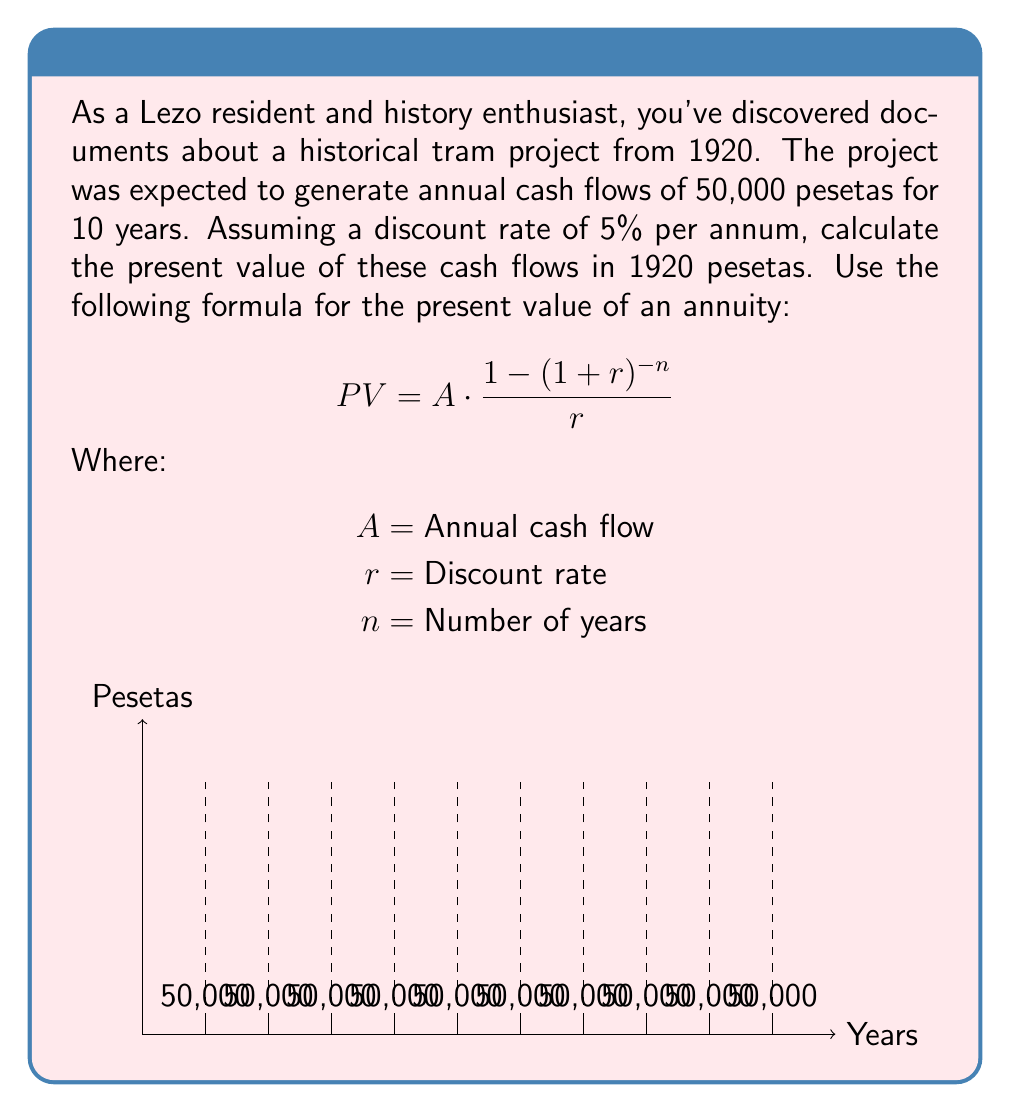Teach me how to tackle this problem. To solve this problem, we'll use the present value of an annuity formula:

$$PV = A \cdot \frac{1 - (1+r)^{-n}}{r}$$

Given:
$A = 50,000$ pesetas (annual cash flow)
$r = 5\% = 0.05$ (discount rate)
$n = 10$ years

Let's substitute these values into the formula:

$$PV = 50,000 \cdot \frac{1 - (1+0.05)^{-10}}{0.05}$$

Now, let's calculate step by step:

1) First, calculate $(1+0.05)^{-10}$:
   $$(1.05)^{-10} \approx 0.6139$$

2) Subtract this from 1:
   $$1 - 0.6139 = 0.3861$$

3) Divide by the discount rate:
   $$\frac{0.3861}{0.05} = 7.7220$$

4) Multiply by the annual cash flow:
   $$50,000 \cdot 7.7220 = 386,100$$

Therefore, the present value of the cash flows is approximately 386,100 pesetas.
Answer: 386,100 pesetas 